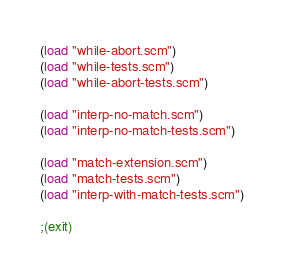Convert code to text. <code><loc_0><loc_0><loc_500><loc_500><_Scheme_>
(load "while-abort.scm")
(load "while-tests.scm")
(load "while-abort-tests.scm")

(load "interp-no-match.scm")
(load "interp-no-match-tests.scm")

(load "match-extension.scm")
(load "match-tests.scm")
(load "interp-with-match-tests.scm")

;(exit)
</code> 